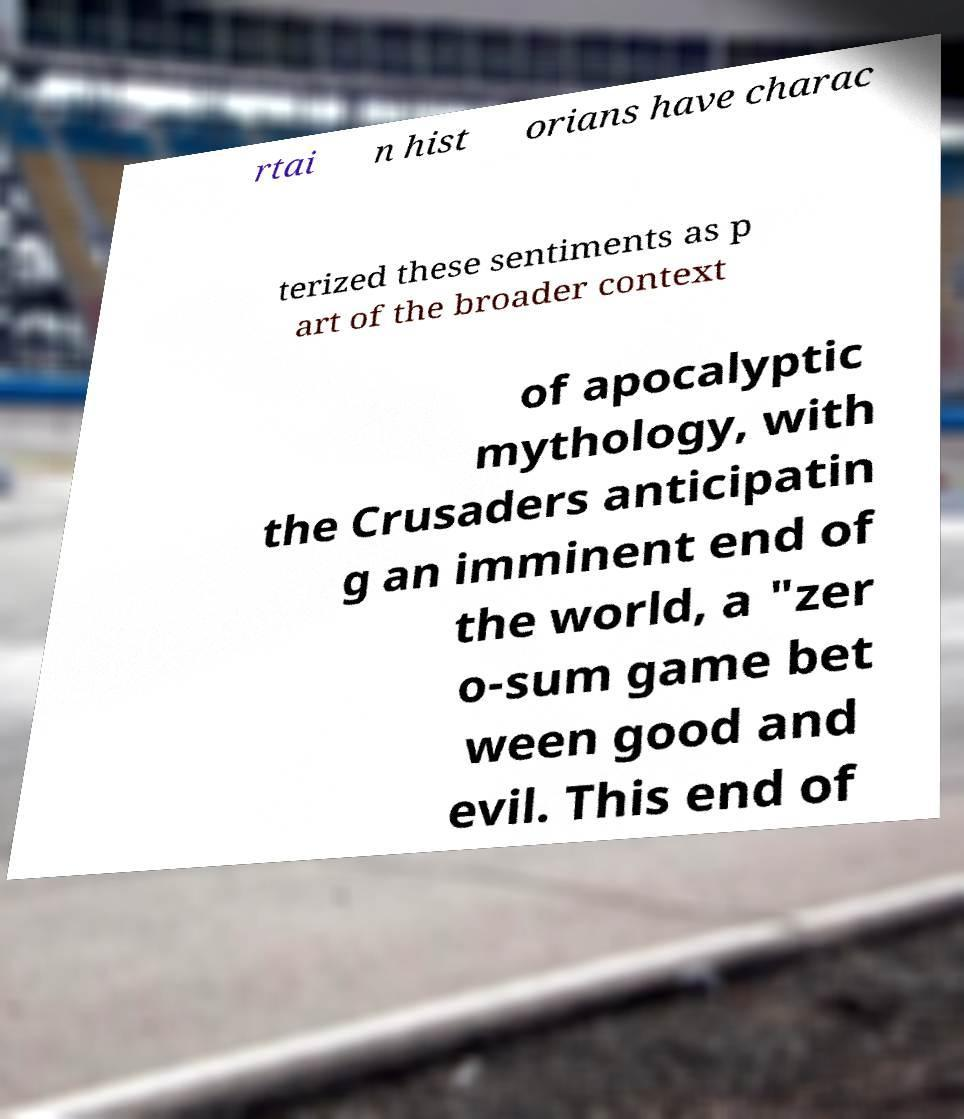Could you extract and type out the text from this image? rtai n hist orians have charac terized these sentiments as p art of the broader context of apocalyptic mythology, with the Crusaders anticipatin g an imminent end of the world, a "zer o-sum game bet ween good and evil. This end of 